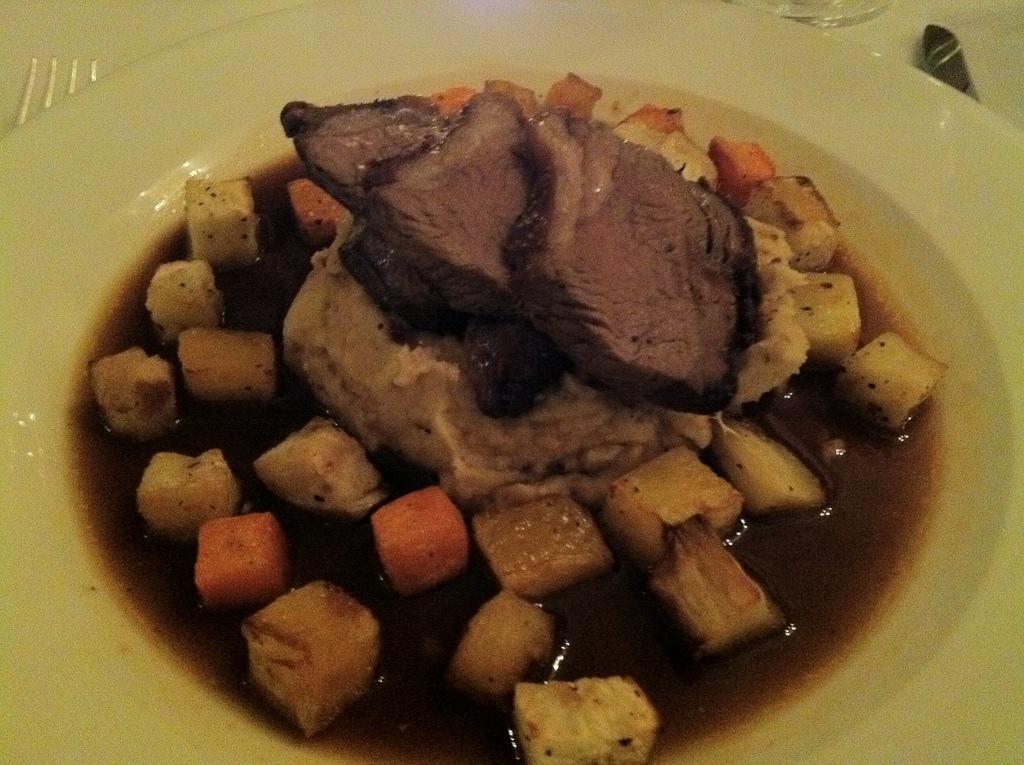Describe this image in one or two sentences. In the picture I can see food items in a plate. I can also see a fork and some other objects. 